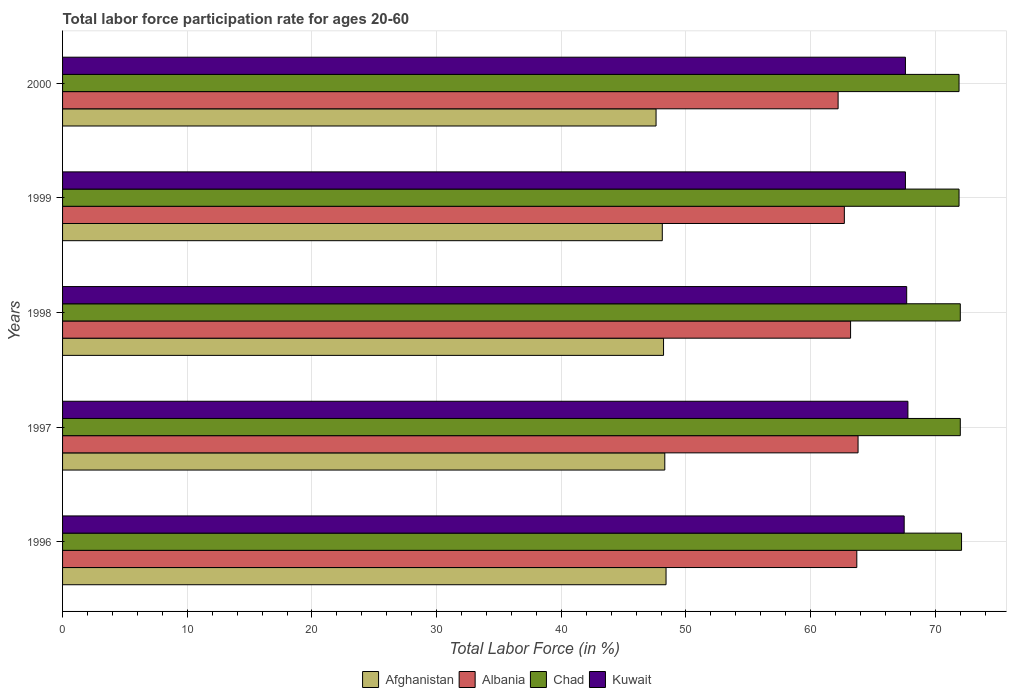How many different coloured bars are there?
Ensure brevity in your answer.  4. Are the number of bars per tick equal to the number of legend labels?
Give a very brief answer. Yes. How many bars are there on the 5th tick from the top?
Provide a short and direct response. 4. How many bars are there on the 3rd tick from the bottom?
Your answer should be compact. 4. What is the label of the 1st group of bars from the top?
Keep it short and to the point. 2000. What is the labor force participation rate in Afghanistan in 2000?
Provide a succinct answer. 47.6. Across all years, what is the maximum labor force participation rate in Albania?
Give a very brief answer. 63.8. Across all years, what is the minimum labor force participation rate in Chad?
Provide a succinct answer. 71.9. In which year was the labor force participation rate in Chad maximum?
Your answer should be very brief. 1996. In which year was the labor force participation rate in Chad minimum?
Your answer should be compact. 1999. What is the total labor force participation rate in Kuwait in the graph?
Provide a succinct answer. 338.2. What is the difference between the labor force participation rate in Chad in 1998 and that in 1999?
Your response must be concise. 0.1. What is the difference between the labor force participation rate in Chad in 2000 and the labor force participation rate in Kuwait in 1999?
Your answer should be very brief. 4.3. What is the average labor force participation rate in Chad per year?
Your answer should be compact. 71.98. In the year 1999, what is the difference between the labor force participation rate in Kuwait and labor force participation rate in Afghanistan?
Make the answer very short. 19.5. In how many years, is the labor force participation rate in Afghanistan greater than 62 %?
Offer a terse response. 0. What is the ratio of the labor force participation rate in Afghanistan in 1999 to that in 2000?
Ensure brevity in your answer.  1.01. Is the difference between the labor force participation rate in Kuwait in 1998 and 2000 greater than the difference between the labor force participation rate in Afghanistan in 1998 and 2000?
Make the answer very short. No. What is the difference between the highest and the second highest labor force participation rate in Afghanistan?
Your answer should be very brief. 0.1. What is the difference between the highest and the lowest labor force participation rate in Kuwait?
Ensure brevity in your answer.  0.3. What does the 2nd bar from the top in 1997 represents?
Ensure brevity in your answer.  Chad. What does the 3rd bar from the bottom in 1999 represents?
Keep it short and to the point. Chad. How many bars are there?
Keep it short and to the point. 20. What is the difference between two consecutive major ticks on the X-axis?
Keep it short and to the point. 10. Are the values on the major ticks of X-axis written in scientific E-notation?
Give a very brief answer. No. Does the graph contain any zero values?
Your answer should be compact. No. Does the graph contain grids?
Provide a succinct answer. Yes. How many legend labels are there?
Provide a succinct answer. 4. What is the title of the graph?
Your response must be concise. Total labor force participation rate for ages 20-60. Does "Sweden" appear as one of the legend labels in the graph?
Keep it short and to the point. No. What is the label or title of the X-axis?
Offer a very short reply. Total Labor Force (in %). What is the label or title of the Y-axis?
Offer a terse response. Years. What is the Total Labor Force (in %) in Afghanistan in 1996?
Your answer should be very brief. 48.4. What is the Total Labor Force (in %) in Albania in 1996?
Your response must be concise. 63.7. What is the Total Labor Force (in %) in Chad in 1996?
Make the answer very short. 72.1. What is the Total Labor Force (in %) in Kuwait in 1996?
Your answer should be very brief. 67.5. What is the Total Labor Force (in %) of Afghanistan in 1997?
Offer a terse response. 48.3. What is the Total Labor Force (in %) of Albania in 1997?
Provide a succinct answer. 63.8. What is the Total Labor Force (in %) in Chad in 1997?
Provide a succinct answer. 72. What is the Total Labor Force (in %) in Kuwait in 1997?
Offer a terse response. 67.8. What is the Total Labor Force (in %) in Afghanistan in 1998?
Provide a short and direct response. 48.2. What is the Total Labor Force (in %) in Albania in 1998?
Your answer should be very brief. 63.2. What is the Total Labor Force (in %) of Chad in 1998?
Offer a very short reply. 72. What is the Total Labor Force (in %) of Kuwait in 1998?
Give a very brief answer. 67.7. What is the Total Labor Force (in %) of Afghanistan in 1999?
Provide a short and direct response. 48.1. What is the Total Labor Force (in %) of Albania in 1999?
Provide a succinct answer. 62.7. What is the Total Labor Force (in %) of Chad in 1999?
Give a very brief answer. 71.9. What is the Total Labor Force (in %) in Kuwait in 1999?
Make the answer very short. 67.6. What is the Total Labor Force (in %) in Afghanistan in 2000?
Ensure brevity in your answer.  47.6. What is the Total Labor Force (in %) in Albania in 2000?
Offer a very short reply. 62.2. What is the Total Labor Force (in %) in Chad in 2000?
Provide a short and direct response. 71.9. What is the Total Labor Force (in %) of Kuwait in 2000?
Give a very brief answer. 67.6. Across all years, what is the maximum Total Labor Force (in %) of Afghanistan?
Keep it short and to the point. 48.4. Across all years, what is the maximum Total Labor Force (in %) of Albania?
Your answer should be compact. 63.8. Across all years, what is the maximum Total Labor Force (in %) in Chad?
Offer a terse response. 72.1. Across all years, what is the maximum Total Labor Force (in %) in Kuwait?
Give a very brief answer. 67.8. Across all years, what is the minimum Total Labor Force (in %) in Afghanistan?
Give a very brief answer. 47.6. Across all years, what is the minimum Total Labor Force (in %) of Albania?
Keep it short and to the point. 62.2. Across all years, what is the minimum Total Labor Force (in %) in Chad?
Ensure brevity in your answer.  71.9. Across all years, what is the minimum Total Labor Force (in %) in Kuwait?
Keep it short and to the point. 67.5. What is the total Total Labor Force (in %) of Afghanistan in the graph?
Provide a succinct answer. 240.6. What is the total Total Labor Force (in %) of Albania in the graph?
Make the answer very short. 315.6. What is the total Total Labor Force (in %) of Chad in the graph?
Ensure brevity in your answer.  359.9. What is the total Total Labor Force (in %) of Kuwait in the graph?
Provide a short and direct response. 338.2. What is the difference between the Total Labor Force (in %) in Chad in 1996 and that in 1997?
Offer a terse response. 0.1. What is the difference between the Total Labor Force (in %) of Kuwait in 1996 and that in 1997?
Your answer should be compact. -0.3. What is the difference between the Total Labor Force (in %) in Albania in 1996 and that in 1998?
Make the answer very short. 0.5. What is the difference between the Total Labor Force (in %) of Chad in 1996 and that in 1998?
Provide a succinct answer. 0.1. What is the difference between the Total Labor Force (in %) of Afghanistan in 1996 and that in 1999?
Give a very brief answer. 0.3. What is the difference between the Total Labor Force (in %) of Kuwait in 1996 and that in 1999?
Offer a terse response. -0.1. What is the difference between the Total Labor Force (in %) of Afghanistan in 1996 and that in 2000?
Ensure brevity in your answer.  0.8. What is the difference between the Total Labor Force (in %) in Albania in 1996 and that in 2000?
Provide a succinct answer. 1.5. What is the difference between the Total Labor Force (in %) of Kuwait in 1996 and that in 2000?
Your response must be concise. -0.1. What is the difference between the Total Labor Force (in %) of Afghanistan in 1997 and that in 1999?
Provide a succinct answer. 0.2. What is the difference between the Total Labor Force (in %) of Chad in 1997 and that in 1999?
Keep it short and to the point. 0.1. What is the difference between the Total Labor Force (in %) of Kuwait in 1997 and that in 1999?
Offer a terse response. 0.2. What is the difference between the Total Labor Force (in %) in Albania in 1997 and that in 2000?
Keep it short and to the point. 1.6. What is the difference between the Total Labor Force (in %) of Chad in 1997 and that in 2000?
Give a very brief answer. 0.1. What is the difference between the Total Labor Force (in %) of Kuwait in 1997 and that in 2000?
Your response must be concise. 0.2. What is the difference between the Total Labor Force (in %) of Albania in 1998 and that in 1999?
Provide a short and direct response. 0.5. What is the difference between the Total Labor Force (in %) of Chad in 1998 and that in 1999?
Offer a terse response. 0.1. What is the difference between the Total Labor Force (in %) of Afghanistan in 1998 and that in 2000?
Ensure brevity in your answer.  0.6. What is the difference between the Total Labor Force (in %) in Chad in 1998 and that in 2000?
Your answer should be very brief. 0.1. What is the difference between the Total Labor Force (in %) of Afghanistan in 1999 and that in 2000?
Offer a very short reply. 0.5. What is the difference between the Total Labor Force (in %) in Afghanistan in 1996 and the Total Labor Force (in %) in Albania in 1997?
Keep it short and to the point. -15.4. What is the difference between the Total Labor Force (in %) of Afghanistan in 1996 and the Total Labor Force (in %) of Chad in 1997?
Offer a terse response. -23.6. What is the difference between the Total Labor Force (in %) of Afghanistan in 1996 and the Total Labor Force (in %) of Kuwait in 1997?
Provide a succinct answer. -19.4. What is the difference between the Total Labor Force (in %) in Afghanistan in 1996 and the Total Labor Force (in %) in Albania in 1998?
Provide a succinct answer. -14.8. What is the difference between the Total Labor Force (in %) in Afghanistan in 1996 and the Total Labor Force (in %) in Chad in 1998?
Ensure brevity in your answer.  -23.6. What is the difference between the Total Labor Force (in %) of Afghanistan in 1996 and the Total Labor Force (in %) of Kuwait in 1998?
Offer a terse response. -19.3. What is the difference between the Total Labor Force (in %) of Albania in 1996 and the Total Labor Force (in %) of Chad in 1998?
Provide a short and direct response. -8.3. What is the difference between the Total Labor Force (in %) in Afghanistan in 1996 and the Total Labor Force (in %) in Albania in 1999?
Offer a very short reply. -14.3. What is the difference between the Total Labor Force (in %) in Afghanistan in 1996 and the Total Labor Force (in %) in Chad in 1999?
Your answer should be very brief. -23.5. What is the difference between the Total Labor Force (in %) in Afghanistan in 1996 and the Total Labor Force (in %) in Kuwait in 1999?
Keep it short and to the point. -19.2. What is the difference between the Total Labor Force (in %) in Albania in 1996 and the Total Labor Force (in %) in Chad in 1999?
Ensure brevity in your answer.  -8.2. What is the difference between the Total Labor Force (in %) of Albania in 1996 and the Total Labor Force (in %) of Kuwait in 1999?
Offer a terse response. -3.9. What is the difference between the Total Labor Force (in %) of Chad in 1996 and the Total Labor Force (in %) of Kuwait in 1999?
Your response must be concise. 4.5. What is the difference between the Total Labor Force (in %) in Afghanistan in 1996 and the Total Labor Force (in %) in Chad in 2000?
Give a very brief answer. -23.5. What is the difference between the Total Labor Force (in %) in Afghanistan in 1996 and the Total Labor Force (in %) in Kuwait in 2000?
Make the answer very short. -19.2. What is the difference between the Total Labor Force (in %) in Chad in 1996 and the Total Labor Force (in %) in Kuwait in 2000?
Give a very brief answer. 4.5. What is the difference between the Total Labor Force (in %) of Afghanistan in 1997 and the Total Labor Force (in %) of Albania in 1998?
Offer a terse response. -14.9. What is the difference between the Total Labor Force (in %) of Afghanistan in 1997 and the Total Labor Force (in %) of Chad in 1998?
Provide a short and direct response. -23.7. What is the difference between the Total Labor Force (in %) of Afghanistan in 1997 and the Total Labor Force (in %) of Kuwait in 1998?
Offer a terse response. -19.4. What is the difference between the Total Labor Force (in %) in Albania in 1997 and the Total Labor Force (in %) in Chad in 1998?
Keep it short and to the point. -8.2. What is the difference between the Total Labor Force (in %) in Albania in 1997 and the Total Labor Force (in %) in Kuwait in 1998?
Make the answer very short. -3.9. What is the difference between the Total Labor Force (in %) of Chad in 1997 and the Total Labor Force (in %) of Kuwait in 1998?
Ensure brevity in your answer.  4.3. What is the difference between the Total Labor Force (in %) in Afghanistan in 1997 and the Total Labor Force (in %) in Albania in 1999?
Make the answer very short. -14.4. What is the difference between the Total Labor Force (in %) in Afghanistan in 1997 and the Total Labor Force (in %) in Chad in 1999?
Give a very brief answer. -23.6. What is the difference between the Total Labor Force (in %) of Afghanistan in 1997 and the Total Labor Force (in %) of Kuwait in 1999?
Provide a short and direct response. -19.3. What is the difference between the Total Labor Force (in %) in Albania in 1997 and the Total Labor Force (in %) in Chad in 1999?
Your answer should be very brief. -8.1. What is the difference between the Total Labor Force (in %) in Albania in 1997 and the Total Labor Force (in %) in Kuwait in 1999?
Provide a succinct answer. -3.8. What is the difference between the Total Labor Force (in %) in Afghanistan in 1997 and the Total Labor Force (in %) in Chad in 2000?
Your answer should be very brief. -23.6. What is the difference between the Total Labor Force (in %) of Afghanistan in 1997 and the Total Labor Force (in %) of Kuwait in 2000?
Your answer should be compact. -19.3. What is the difference between the Total Labor Force (in %) of Chad in 1997 and the Total Labor Force (in %) of Kuwait in 2000?
Your response must be concise. 4.4. What is the difference between the Total Labor Force (in %) in Afghanistan in 1998 and the Total Labor Force (in %) in Albania in 1999?
Provide a short and direct response. -14.5. What is the difference between the Total Labor Force (in %) of Afghanistan in 1998 and the Total Labor Force (in %) of Chad in 1999?
Provide a succinct answer. -23.7. What is the difference between the Total Labor Force (in %) in Afghanistan in 1998 and the Total Labor Force (in %) in Kuwait in 1999?
Give a very brief answer. -19.4. What is the difference between the Total Labor Force (in %) of Albania in 1998 and the Total Labor Force (in %) of Chad in 1999?
Offer a terse response. -8.7. What is the difference between the Total Labor Force (in %) of Afghanistan in 1998 and the Total Labor Force (in %) of Chad in 2000?
Your answer should be very brief. -23.7. What is the difference between the Total Labor Force (in %) in Afghanistan in 1998 and the Total Labor Force (in %) in Kuwait in 2000?
Ensure brevity in your answer.  -19.4. What is the difference between the Total Labor Force (in %) in Afghanistan in 1999 and the Total Labor Force (in %) in Albania in 2000?
Your response must be concise. -14.1. What is the difference between the Total Labor Force (in %) of Afghanistan in 1999 and the Total Labor Force (in %) of Chad in 2000?
Keep it short and to the point. -23.8. What is the difference between the Total Labor Force (in %) of Afghanistan in 1999 and the Total Labor Force (in %) of Kuwait in 2000?
Ensure brevity in your answer.  -19.5. What is the difference between the Total Labor Force (in %) in Albania in 1999 and the Total Labor Force (in %) in Kuwait in 2000?
Offer a terse response. -4.9. What is the average Total Labor Force (in %) of Afghanistan per year?
Give a very brief answer. 48.12. What is the average Total Labor Force (in %) of Albania per year?
Your answer should be compact. 63.12. What is the average Total Labor Force (in %) of Chad per year?
Give a very brief answer. 71.98. What is the average Total Labor Force (in %) in Kuwait per year?
Offer a terse response. 67.64. In the year 1996, what is the difference between the Total Labor Force (in %) of Afghanistan and Total Labor Force (in %) of Albania?
Provide a short and direct response. -15.3. In the year 1996, what is the difference between the Total Labor Force (in %) of Afghanistan and Total Labor Force (in %) of Chad?
Your answer should be compact. -23.7. In the year 1996, what is the difference between the Total Labor Force (in %) in Afghanistan and Total Labor Force (in %) in Kuwait?
Offer a very short reply. -19.1. In the year 1996, what is the difference between the Total Labor Force (in %) of Albania and Total Labor Force (in %) of Chad?
Make the answer very short. -8.4. In the year 1997, what is the difference between the Total Labor Force (in %) in Afghanistan and Total Labor Force (in %) in Albania?
Your answer should be compact. -15.5. In the year 1997, what is the difference between the Total Labor Force (in %) in Afghanistan and Total Labor Force (in %) in Chad?
Give a very brief answer. -23.7. In the year 1997, what is the difference between the Total Labor Force (in %) of Afghanistan and Total Labor Force (in %) of Kuwait?
Your answer should be very brief. -19.5. In the year 1997, what is the difference between the Total Labor Force (in %) of Albania and Total Labor Force (in %) of Chad?
Your answer should be very brief. -8.2. In the year 1998, what is the difference between the Total Labor Force (in %) of Afghanistan and Total Labor Force (in %) of Chad?
Make the answer very short. -23.8. In the year 1998, what is the difference between the Total Labor Force (in %) of Afghanistan and Total Labor Force (in %) of Kuwait?
Your answer should be compact. -19.5. In the year 1998, what is the difference between the Total Labor Force (in %) of Albania and Total Labor Force (in %) of Kuwait?
Provide a succinct answer. -4.5. In the year 1999, what is the difference between the Total Labor Force (in %) in Afghanistan and Total Labor Force (in %) in Albania?
Ensure brevity in your answer.  -14.6. In the year 1999, what is the difference between the Total Labor Force (in %) in Afghanistan and Total Labor Force (in %) in Chad?
Your response must be concise. -23.8. In the year 1999, what is the difference between the Total Labor Force (in %) in Afghanistan and Total Labor Force (in %) in Kuwait?
Provide a succinct answer. -19.5. In the year 1999, what is the difference between the Total Labor Force (in %) in Albania and Total Labor Force (in %) in Chad?
Give a very brief answer. -9.2. In the year 2000, what is the difference between the Total Labor Force (in %) of Afghanistan and Total Labor Force (in %) of Albania?
Your answer should be very brief. -14.6. In the year 2000, what is the difference between the Total Labor Force (in %) in Afghanistan and Total Labor Force (in %) in Chad?
Keep it short and to the point. -24.3. In the year 2000, what is the difference between the Total Labor Force (in %) of Afghanistan and Total Labor Force (in %) of Kuwait?
Give a very brief answer. -20. What is the ratio of the Total Labor Force (in %) in Kuwait in 1996 to that in 1997?
Provide a short and direct response. 1. What is the ratio of the Total Labor Force (in %) of Afghanistan in 1996 to that in 1998?
Ensure brevity in your answer.  1. What is the ratio of the Total Labor Force (in %) in Albania in 1996 to that in 1998?
Provide a short and direct response. 1.01. What is the ratio of the Total Labor Force (in %) of Chad in 1996 to that in 1998?
Make the answer very short. 1. What is the ratio of the Total Labor Force (in %) in Albania in 1996 to that in 1999?
Give a very brief answer. 1.02. What is the ratio of the Total Labor Force (in %) of Chad in 1996 to that in 1999?
Provide a succinct answer. 1. What is the ratio of the Total Labor Force (in %) of Kuwait in 1996 to that in 1999?
Keep it short and to the point. 1. What is the ratio of the Total Labor Force (in %) of Afghanistan in 1996 to that in 2000?
Make the answer very short. 1.02. What is the ratio of the Total Labor Force (in %) of Albania in 1996 to that in 2000?
Offer a terse response. 1.02. What is the ratio of the Total Labor Force (in %) in Kuwait in 1996 to that in 2000?
Make the answer very short. 1. What is the ratio of the Total Labor Force (in %) of Albania in 1997 to that in 1998?
Your answer should be very brief. 1.01. What is the ratio of the Total Labor Force (in %) of Chad in 1997 to that in 1998?
Offer a terse response. 1. What is the ratio of the Total Labor Force (in %) in Kuwait in 1997 to that in 1998?
Offer a very short reply. 1. What is the ratio of the Total Labor Force (in %) of Albania in 1997 to that in 1999?
Your response must be concise. 1.02. What is the ratio of the Total Labor Force (in %) in Afghanistan in 1997 to that in 2000?
Ensure brevity in your answer.  1.01. What is the ratio of the Total Labor Force (in %) of Albania in 1997 to that in 2000?
Your answer should be very brief. 1.03. What is the ratio of the Total Labor Force (in %) of Chad in 1997 to that in 2000?
Give a very brief answer. 1. What is the ratio of the Total Labor Force (in %) in Afghanistan in 1998 to that in 2000?
Your answer should be compact. 1.01. What is the ratio of the Total Labor Force (in %) of Albania in 1998 to that in 2000?
Make the answer very short. 1.02. What is the ratio of the Total Labor Force (in %) in Afghanistan in 1999 to that in 2000?
Your answer should be compact. 1.01. What is the ratio of the Total Labor Force (in %) in Kuwait in 1999 to that in 2000?
Ensure brevity in your answer.  1. What is the difference between the highest and the second highest Total Labor Force (in %) of Chad?
Keep it short and to the point. 0.1. 